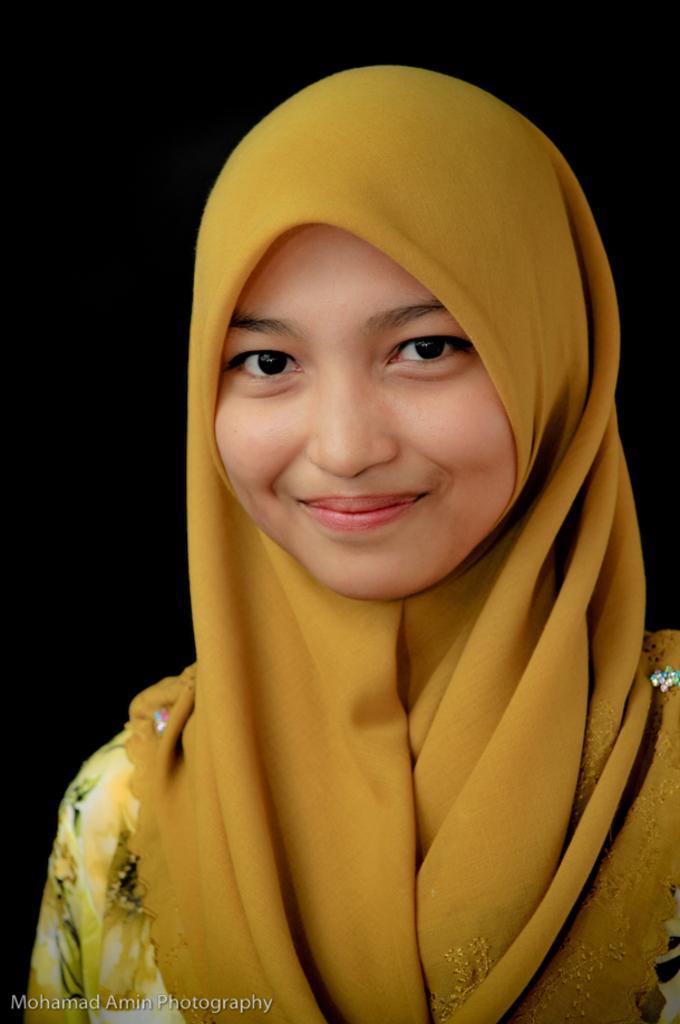Can you describe this image briefly? In this image we can see a woman wearing a scarf. On the bottom of the image we can see some text. 